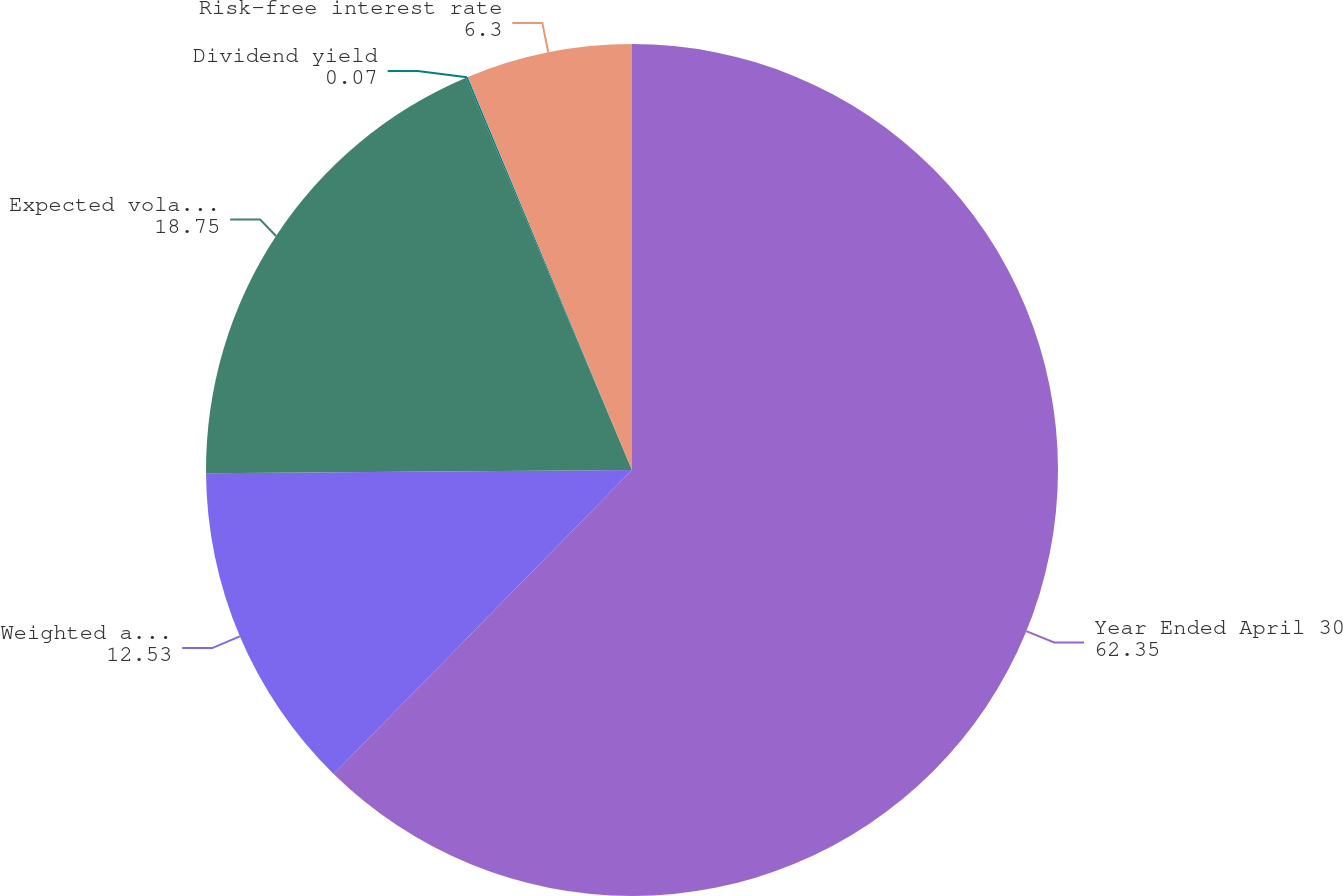Convert chart to OTSL. <chart><loc_0><loc_0><loc_500><loc_500><pie_chart><fcel>Year Ended April 30<fcel>Weighted average fair value<fcel>Expected volatility<fcel>Dividend yield<fcel>Risk-free interest rate<nl><fcel>62.35%<fcel>12.53%<fcel>18.75%<fcel>0.07%<fcel>6.3%<nl></chart> 